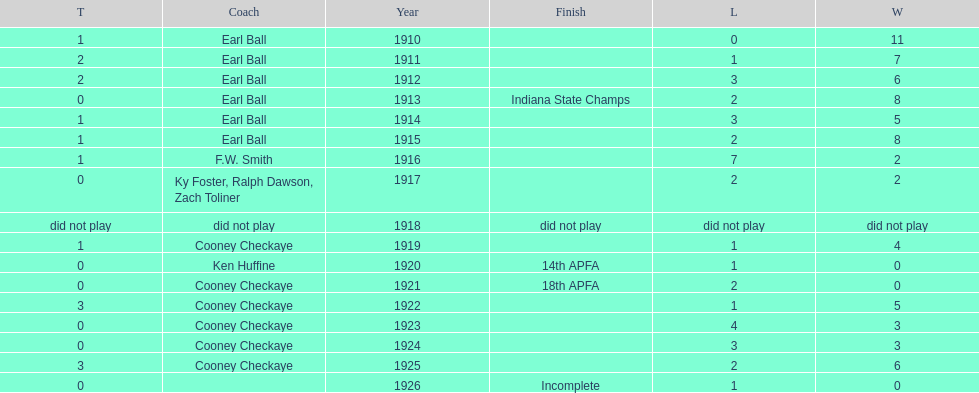Between 1910 and 1925, the muncie flyers played every year except one. what was the year they didn't play? 1918. 